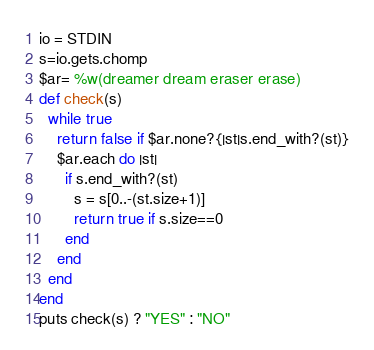Convert code to text. <code><loc_0><loc_0><loc_500><loc_500><_Ruby_>io = STDIN
s=io.gets.chomp
$ar= %w(dreamer dream eraser erase)
def check(s)
  while true
    return false if $ar.none?{|st|s.end_with?(st)}
    $ar.each do |st|
      if s.end_with?(st)
        s = s[0..-(st.size+1)]
        return true if s.size==0
      end
    end
  end
end
puts check(s) ? "YES" : "NO"</code> 